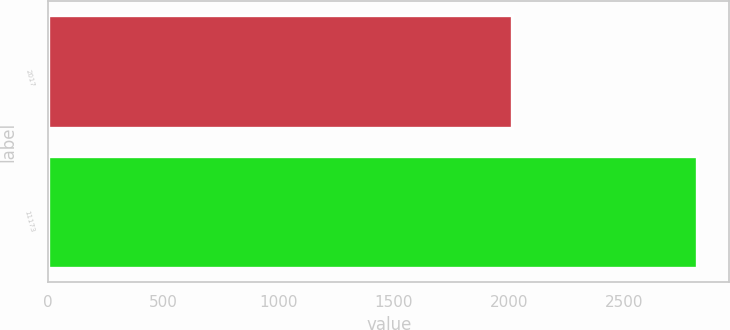Convert chart to OTSL. <chart><loc_0><loc_0><loc_500><loc_500><bar_chart><fcel>2017<fcel>11173<nl><fcel>2014<fcel>2815<nl></chart> 